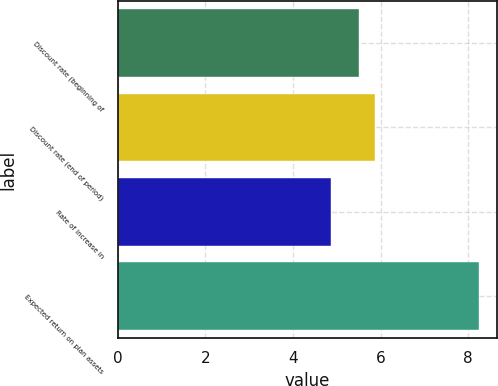Convert chart. <chart><loc_0><loc_0><loc_500><loc_500><bar_chart><fcel>Discount rate (beginning of<fcel>Discount rate (end of period)<fcel>Rate of increase in<fcel>Expected return on plan assets<nl><fcel>5.5<fcel>5.88<fcel>4.88<fcel>8.25<nl></chart> 